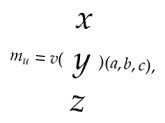Convert formula to latex. <formula><loc_0><loc_0><loc_500><loc_500>m _ { u } = v ( \begin{array} { c } x \\ y \\ z \end{array} ) ( a , b , c ) ,</formula> 